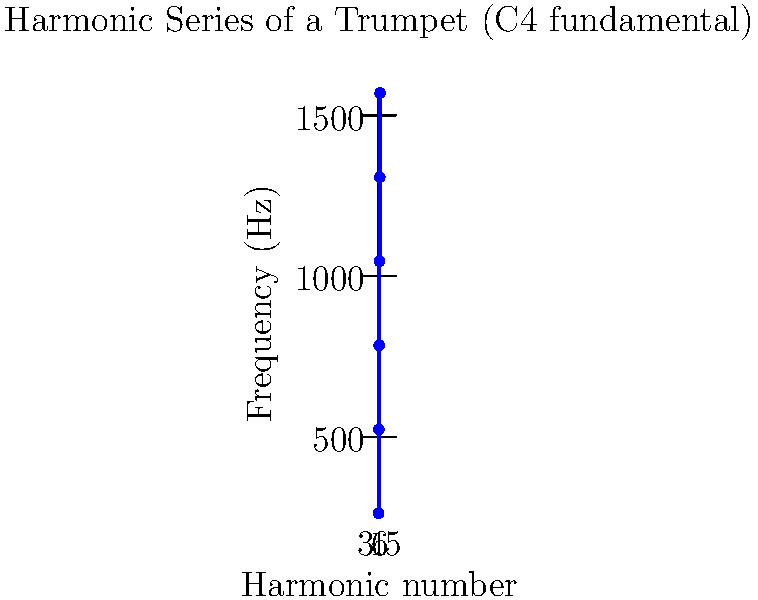As a jazz musician familiar with trumpet harmonics, analyze the graph showing the harmonic series of a trumpet with a fundamental frequency of 261.6 Hz (C4). What is the frequency difference between adjacent harmonics, and how does this relate to the fundamental frequency? To answer this question, let's analyze the graph step-by-step:

1. Observe that the x-axis represents the harmonic number, and the y-axis represents the frequency in Hz.

2. The fundamental frequency (1st harmonic) is given as 261.6 Hz (C4).

3. Let's calculate the frequency difference between adjacent harmonics:
   - Between 1st and 2nd: 523.2 Hz - 261.6 Hz = 261.6 Hz
   - Between 2nd and 3rd: 784.8 Hz - 523.2 Hz = 261.6 Hz
   - Between 3rd and 4th: 1046.4 Hz - 784.8 Hz = 261.6 Hz
   - And so on...

4. We can see that the frequency difference between adjacent harmonics is constant and equal to 261.6 Hz.

5. This constant difference is exactly equal to the fundamental frequency.

6. In general, for any harmonic series:
   $f_n = n \cdot f_1$
   where $f_n$ is the frequency of the nth harmonic, and $f_1$ is the fundamental frequency.

7. The difference between adjacent harmonics is always equal to the fundamental frequency:
   $f_{n+1} - f_n = (n+1)f_1 - nf_1 = f_1$

This relationship between the fundamental frequency and the frequency difference between adjacent harmonics is a key characteristic of the harmonic series, which is crucial in understanding the overtones produced by a trumpet and other musical instruments.
Answer: 261.6 Hz, equal to the fundamental frequency 